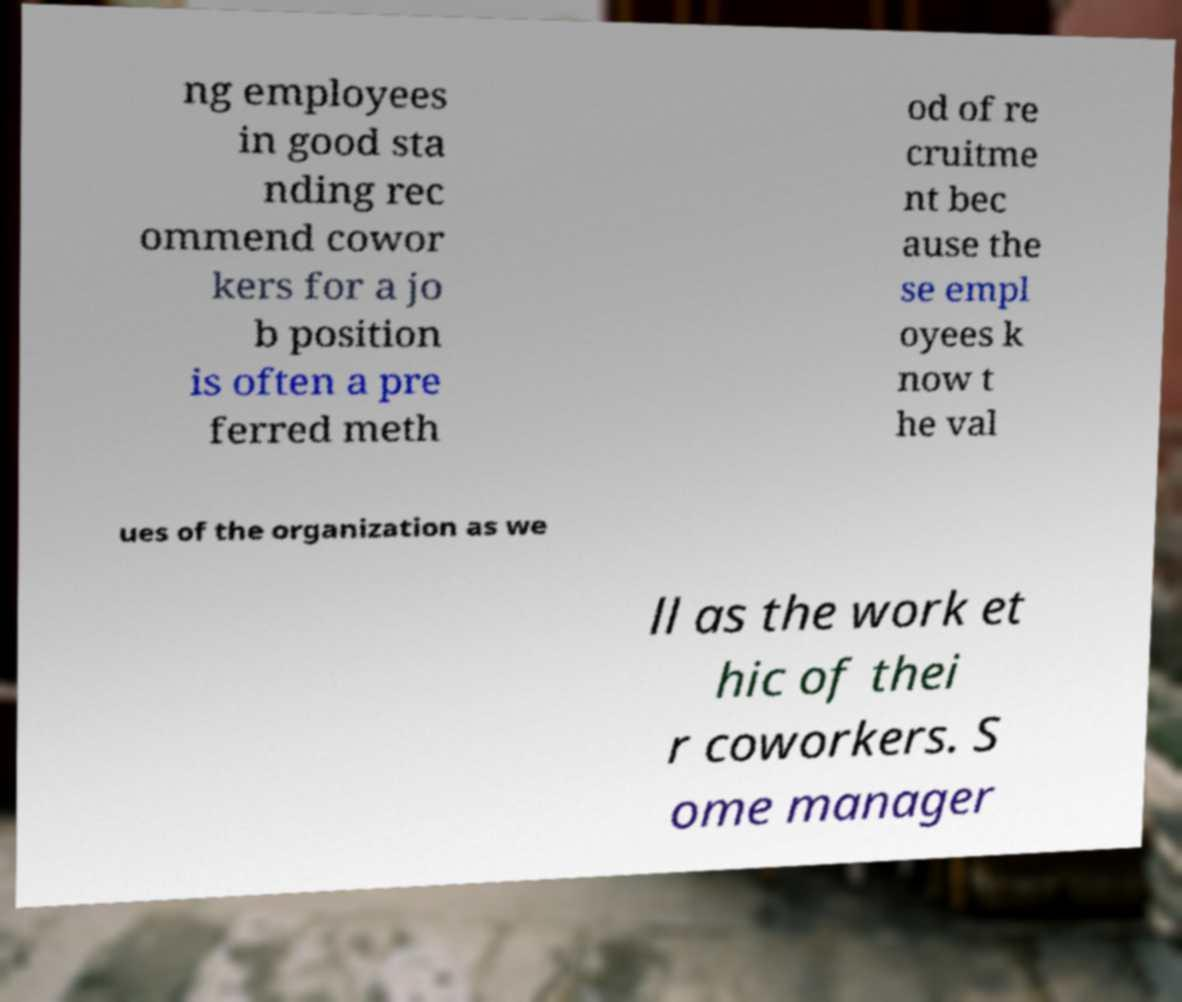Could you assist in decoding the text presented in this image and type it out clearly? ng employees in good sta nding rec ommend cowor kers for a jo b position is often a pre ferred meth od of re cruitme nt bec ause the se empl oyees k now t he val ues of the organization as we ll as the work et hic of thei r coworkers. S ome manager 